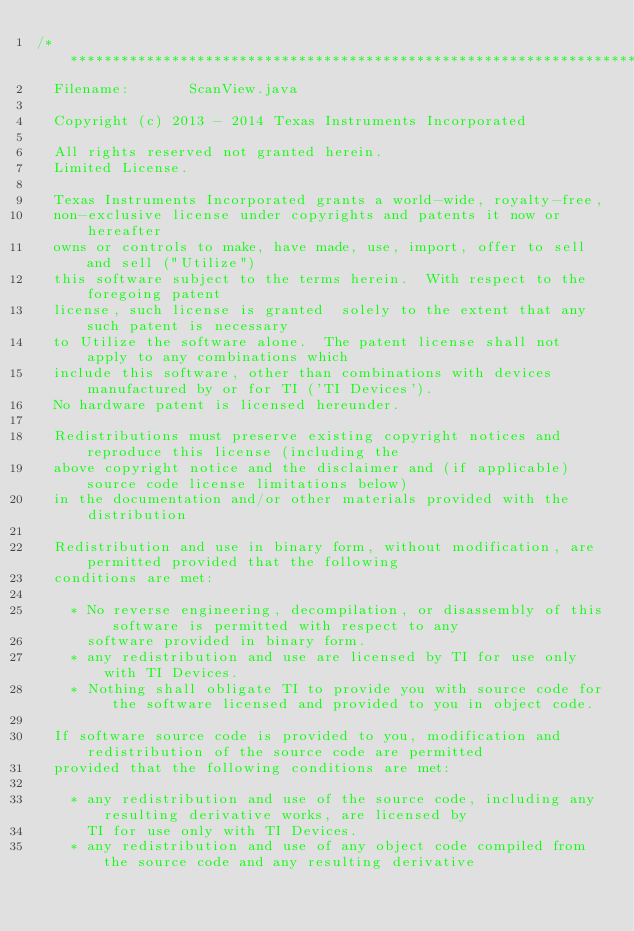Convert code to text. <code><loc_0><loc_0><loc_500><loc_500><_Java_>/**************************************************************************************************
  Filename:       ScanView.java

  Copyright (c) 2013 - 2014 Texas Instruments Incorporated

  All rights reserved not granted herein.
  Limited License. 

  Texas Instruments Incorporated grants a world-wide, royalty-free,
  non-exclusive license under copyrights and patents it now or hereafter
  owns or controls to make, have made, use, import, offer to sell and sell ("Utilize")
  this software subject to the terms herein.  With respect to the foregoing patent
  license, such license is granted  solely to the extent that any such patent is necessary
  to Utilize the software alone.  The patent license shall not apply to any combinations which
  include this software, other than combinations with devices manufactured by or for TI ('TI Devices').
  No hardware patent is licensed hereunder.

  Redistributions must preserve existing copyright notices and reproduce this license (including the
  above copyright notice and the disclaimer and (if applicable) source code license limitations below)
  in the documentation and/or other materials provided with the distribution

  Redistribution and use in binary form, without modification, are permitted provided that the following
  conditions are met:

    * No reverse engineering, decompilation, or disassembly of this software is permitted with respect to any
      software provided in binary form.
    * any redistribution and use are licensed by TI for use only with TI Devices.
    * Nothing shall obligate TI to provide you with source code for the software licensed and provided to you in object code.

  If software source code is provided to you, modification and redistribution of the source code are permitted
  provided that the following conditions are met:

    * any redistribution and use of the source code, including any resulting derivative works, are licensed by
      TI for use only with TI Devices.
    * any redistribution and use of any object code compiled from the source code and any resulting derivative</code> 